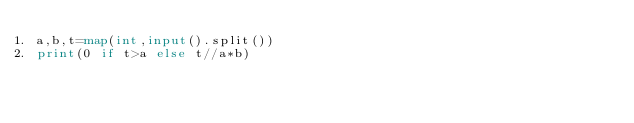Convert code to text. <code><loc_0><loc_0><loc_500><loc_500><_Python_>a,b,t=map(int,input().split())
print(0 if t>a else t//a*b)</code> 